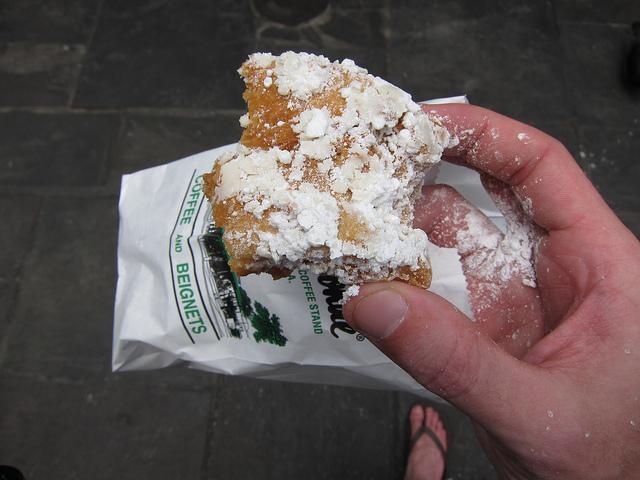How many hands are in the picture?
Answer briefly. 1. Which hand is it?
Write a very short answer. Right. Is someone holding it?
Short answer required. Yes. What is this pastry called?
Quick response, please. Beignet. What is on top of the pastry?
Be succinct. Sugar. What is in this person's hand?
Be succinct. Dessert. With which hand is the person eating with?
Quick response, please. Right. 